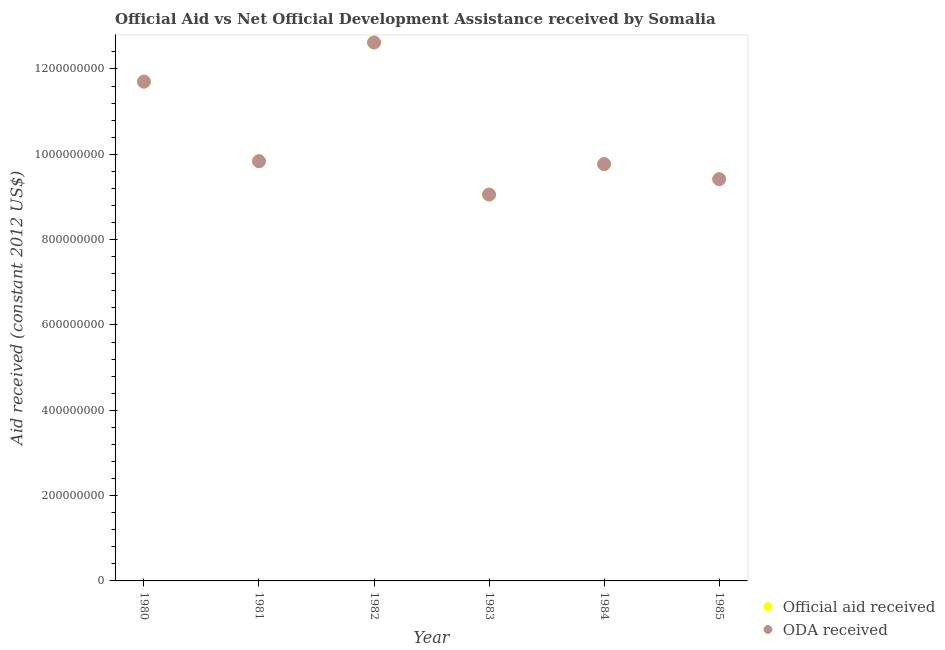How many different coloured dotlines are there?
Your answer should be very brief. 2. Is the number of dotlines equal to the number of legend labels?
Provide a succinct answer. Yes. What is the official aid received in 1984?
Your response must be concise. 9.77e+08. Across all years, what is the maximum oda received?
Your response must be concise. 1.26e+09. Across all years, what is the minimum official aid received?
Keep it short and to the point. 9.06e+08. In which year was the official aid received maximum?
Give a very brief answer. 1982. In which year was the oda received minimum?
Give a very brief answer. 1983. What is the total oda received in the graph?
Keep it short and to the point. 6.24e+09. What is the difference between the oda received in 1983 and that in 1984?
Keep it short and to the point. -7.14e+07. What is the difference between the official aid received in 1981 and the oda received in 1984?
Your answer should be compact. 6.79e+06. What is the average oda received per year?
Keep it short and to the point. 1.04e+09. In the year 1980, what is the difference between the official aid received and oda received?
Your answer should be very brief. 0. What is the ratio of the official aid received in 1981 to that in 1985?
Your answer should be very brief. 1.04. Is the official aid received in 1980 less than that in 1982?
Provide a succinct answer. Yes. What is the difference between the highest and the second highest official aid received?
Provide a succinct answer. 9.18e+07. What is the difference between the highest and the lowest oda received?
Make the answer very short. 3.57e+08. In how many years, is the oda received greater than the average oda received taken over all years?
Your answer should be very brief. 2. Is the sum of the official aid received in 1982 and 1985 greater than the maximum oda received across all years?
Keep it short and to the point. Yes. Does the official aid received monotonically increase over the years?
Provide a short and direct response. No. How many dotlines are there?
Give a very brief answer. 2. What is the difference between two consecutive major ticks on the Y-axis?
Provide a succinct answer. 2.00e+08. Are the values on the major ticks of Y-axis written in scientific E-notation?
Your answer should be compact. No. Does the graph contain any zero values?
Offer a terse response. No. How many legend labels are there?
Make the answer very short. 2. How are the legend labels stacked?
Offer a terse response. Vertical. What is the title of the graph?
Make the answer very short. Official Aid vs Net Official Development Assistance received by Somalia . What is the label or title of the Y-axis?
Your response must be concise. Aid received (constant 2012 US$). What is the Aid received (constant 2012 US$) in Official aid received in 1980?
Your response must be concise. 1.17e+09. What is the Aid received (constant 2012 US$) of ODA received in 1980?
Ensure brevity in your answer.  1.17e+09. What is the Aid received (constant 2012 US$) in Official aid received in 1981?
Your answer should be very brief. 9.84e+08. What is the Aid received (constant 2012 US$) in ODA received in 1981?
Your answer should be very brief. 9.84e+08. What is the Aid received (constant 2012 US$) in Official aid received in 1982?
Offer a terse response. 1.26e+09. What is the Aid received (constant 2012 US$) in ODA received in 1982?
Provide a succinct answer. 1.26e+09. What is the Aid received (constant 2012 US$) of Official aid received in 1983?
Your answer should be very brief. 9.06e+08. What is the Aid received (constant 2012 US$) in ODA received in 1983?
Provide a succinct answer. 9.06e+08. What is the Aid received (constant 2012 US$) of Official aid received in 1984?
Ensure brevity in your answer.  9.77e+08. What is the Aid received (constant 2012 US$) of ODA received in 1984?
Your response must be concise. 9.77e+08. What is the Aid received (constant 2012 US$) of Official aid received in 1985?
Offer a very short reply. 9.42e+08. What is the Aid received (constant 2012 US$) in ODA received in 1985?
Make the answer very short. 9.42e+08. Across all years, what is the maximum Aid received (constant 2012 US$) of Official aid received?
Keep it short and to the point. 1.26e+09. Across all years, what is the maximum Aid received (constant 2012 US$) in ODA received?
Your response must be concise. 1.26e+09. Across all years, what is the minimum Aid received (constant 2012 US$) in Official aid received?
Provide a succinct answer. 9.06e+08. Across all years, what is the minimum Aid received (constant 2012 US$) of ODA received?
Your answer should be very brief. 9.06e+08. What is the total Aid received (constant 2012 US$) of Official aid received in the graph?
Offer a terse response. 6.24e+09. What is the total Aid received (constant 2012 US$) of ODA received in the graph?
Keep it short and to the point. 6.24e+09. What is the difference between the Aid received (constant 2012 US$) of Official aid received in 1980 and that in 1981?
Ensure brevity in your answer.  1.87e+08. What is the difference between the Aid received (constant 2012 US$) of ODA received in 1980 and that in 1981?
Make the answer very short. 1.87e+08. What is the difference between the Aid received (constant 2012 US$) in Official aid received in 1980 and that in 1982?
Make the answer very short. -9.18e+07. What is the difference between the Aid received (constant 2012 US$) of ODA received in 1980 and that in 1982?
Provide a succinct answer. -9.18e+07. What is the difference between the Aid received (constant 2012 US$) of Official aid received in 1980 and that in 1983?
Give a very brief answer. 2.65e+08. What is the difference between the Aid received (constant 2012 US$) in ODA received in 1980 and that in 1983?
Offer a terse response. 2.65e+08. What is the difference between the Aid received (constant 2012 US$) of Official aid received in 1980 and that in 1984?
Offer a terse response. 1.93e+08. What is the difference between the Aid received (constant 2012 US$) of ODA received in 1980 and that in 1984?
Ensure brevity in your answer.  1.93e+08. What is the difference between the Aid received (constant 2012 US$) in Official aid received in 1980 and that in 1985?
Your answer should be very brief. 2.29e+08. What is the difference between the Aid received (constant 2012 US$) in ODA received in 1980 and that in 1985?
Your response must be concise. 2.29e+08. What is the difference between the Aid received (constant 2012 US$) in Official aid received in 1981 and that in 1982?
Your answer should be very brief. -2.78e+08. What is the difference between the Aid received (constant 2012 US$) in ODA received in 1981 and that in 1982?
Your response must be concise. -2.78e+08. What is the difference between the Aid received (constant 2012 US$) in Official aid received in 1981 and that in 1983?
Your answer should be very brief. 7.82e+07. What is the difference between the Aid received (constant 2012 US$) in ODA received in 1981 and that in 1983?
Ensure brevity in your answer.  7.82e+07. What is the difference between the Aid received (constant 2012 US$) in Official aid received in 1981 and that in 1984?
Provide a succinct answer. 6.79e+06. What is the difference between the Aid received (constant 2012 US$) in ODA received in 1981 and that in 1984?
Offer a terse response. 6.79e+06. What is the difference between the Aid received (constant 2012 US$) in Official aid received in 1981 and that in 1985?
Offer a terse response. 4.21e+07. What is the difference between the Aid received (constant 2012 US$) of ODA received in 1981 and that in 1985?
Your response must be concise. 4.21e+07. What is the difference between the Aid received (constant 2012 US$) in Official aid received in 1982 and that in 1983?
Ensure brevity in your answer.  3.57e+08. What is the difference between the Aid received (constant 2012 US$) of ODA received in 1982 and that in 1983?
Offer a terse response. 3.57e+08. What is the difference between the Aid received (constant 2012 US$) of Official aid received in 1982 and that in 1984?
Your answer should be very brief. 2.85e+08. What is the difference between the Aid received (constant 2012 US$) of ODA received in 1982 and that in 1984?
Your answer should be compact. 2.85e+08. What is the difference between the Aid received (constant 2012 US$) of Official aid received in 1982 and that in 1985?
Offer a terse response. 3.20e+08. What is the difference between the Aid received (constant 2012 US$) in ODA received in 1982 and that in 1985?
Ensure brevity in your answer.  3.20e+08. What is the difference between the Aid received (constant 2012 US$) in Official aid received in 1983 and that in 1984?
Ensure brevity in your answer.  -7.14e+07. What is the difference between the Aid received (constant 2012 US$) in ODA received in 1983 and that in 1984?
Provide a succinct answer. -7.14e+07. What is the difference between the Aid received (constant 2012 US$) of Official aid received in 1983 and that in 1985?
Give a very brief answer. -3.61e+07. What is the difference between the Aid received (constant 2012 US$) in ODA received in 1983 and that in 1985?
Ensure brevity in your answer.  -3.61e+07. What is the difference between the Aid received (constant 2012 US$) in Official aid received in 1984 and that in 1985?
Your answer should be compact. 3.53e+07. What is the difference between the Aid received (constant 2012 US$) of ODA received in 1984 and that in 1985?
Keep it short and to the point. 3.53e+07. What is the difference between the Aid received (constant 2012 US$) in Official aid received in 1980 and the Aid received (constant 2012 US$) in ODA received in 1981?
Give a very brief answer. 1.87e+08. What is the difference between the Aid received (constant 2012 US$) in Official aid received in 1980 and the Aid received (constant 2012 US$) in ODA received in 1982?
Offer a very short reply. -9.18e+07. What is the difference between the Aid received (constant 2012 US$) of Official aid received in 1980 and the Aid received (constant 2012 US$) of ODA received in 1983?
Make the answer very short. 2.65e+08. What is the difference between the Aid received (constant 2012 US$) in Official aid received in 1980 and the Aid received (constant 2012 US$) in ODA received in 1984?
Ensure brevity in your answer.  1.93e+08. What is the difference between the Aid received (constant 2012 US$) of Official aid received in 1980 and the Aid received (constant 2012 US$) of ODA received in 1985?
Provide a succinct answer. 2.29e+08. What is the difference between the Aid received (constant 2012 US$) of Official aid received in 1981 and the Aid received (constant 2012 US$) of ODA received in 1982?
Offer a very short reply. -2.78e+08. What is the difference between the Aid received (constant 2012 US$) in Official aid received in 1981 and the Aid received (constant 2012 US$) in ODA received in 1983?
Provide a succinct answer. 7.82e+07. What is the difference between the Aid received (constant 2012 US$) in Official aid received in 1981 and the Aid received (constant 2012 US$) in ODA received in 1984?
Give a very brief answer. 6.79e+06. What is the difference between the Aid received (constant 2012 US$) in Official aid received in 1981 and the Aid received (constant 2012 US$) in ODA received in 1985?
Your answer should be compact. 4.21e+07. What is the difference between the Aid received (constant 2012 US$) in Official aid received in 1982 and the Aid received (constant 2012 US$) in ODA received in 1983?
Give a very brief answer. 3.57e+08. What is the difference between the Aid received (constant 2012 US$) in Official aid received in 1982 and the Aid received (constant 2012 US$) in ODA received in 1984?
Make the answer very short. 2.85e+08. What is the difference between the Aid received (constant 2012 US$) of Official aid received in 1982 and the Aid received (constant 2012 US$) of ODA received in 1985?
Offer a terse response. 3.20e+08. What is the difference between the Aid received (constant 2012 US$) of Official aid received in 1983 and the Aid received (constant 2012 US$) of ODA received in 1984?
Provide a short and direct response. -7.14e+07. What is the difference between the Aid received (constant 2012 US$) in Official aid received in 1983 and the Aid received (constant 2012 US$) in ODA received in 1985?
Offer a terse response. -3.61e+07. What is the difference between the Aid received (constant 2012 US$) of Official aid received in 1984 and the Aid received (constant 2012 US$) of ODA received in 1985?
Your answer should be very brief. 3.53e+07. What is the average Aid received (constant 2012 US$) of Official aid received per year?
Your answer should be compact. 1.04e+09. What is the average Aid received (constant 2012 US$) in ODA received per year?
Keep it short and to the point. 1.04e+09. In the year 1983, what is the difference between the Aid received (constant 2012 US$) in Official aid received and Aid received (constant 2012 US$) in ODA received?
Provide a short and direct response. 0. In the year 1984, what is the difference between the Aid received (constant 2012 US$) in Official aid received and Aid received (constant 2012 US$) in ODA received?
Provide a short and direct response. 0. What is the ratio of the Aid received (constant 2012 US$) of Official aid received in 1980 to that in 1981?
Your answer should be very brief. 1.19. What is the ratio of the Aid received (constant 2012 US$) in ODA received in 1980 to that in 1981?
Ensure brevity in your answer.  1.19. What is the ratio of the Aid received (constant 2012 US$) of Official aid received in 1980 to that in 1982?
Keep it short and to the point. 0.93. What is the ratio of the Aid received (constant 2012 US$) of ODA received in 1980 to that in 1982?
Offer a very short reply. 0.93. What is the ratio of the Aid received (constant 2012 US$) in Official aid received in 1980 to that in 1983?
Your response must be concise. 1.29. What is the ratio of the Aid received (constant 2012 US$) of ODA received in 1980 to that in 1983?
Your response must be concise. 1.29. What is the ratio of the Aid received (constant 2012 US$) in Official aid received in 1980 to that in 1984?
Provide a succinct answer. 1.2. What is the ratio of the Aid received (constant 2012 US$) of ODA received in 1980 to that in 1984?
Keep it short and to the point. 1.2. What is the ratio of the Aid received (constant 2012 US$) of Official aid received in 1980 to that in 1985?
Ensure brevity in your answer.  1.24. What is the ratio of the Aid received (constant 2012 US$) of ODA received in 1980 to that in 1985?
Keep it short and to the point. 1.24. What is the ratio of the Aid received (constant 2012 US$) in Official aid received in 1981 to that in 1982?
Ensure brevity in your answer.  0.78. What is the ratio of the Aid received (constant 2012 US$) of ODA received in 1981 to that in 1982?
Keep it short and to the point. 0.78. What is the ratio of the Aid received (constant 2012 US$) of Official aid received in 1981 to that in 1983?
Your answer should be very brief. 1.09. What is the ratio of the Aid received (constant 2012 US$) in ODA received in 1981 to that in 1983?
Keep it short and to the point. 1.09. What is the ratio of the Aid received (constant 2012 US$) in Official aid received in 1981 to that in 1985?
Ensure brevity in your answer.  1.04. What is the ratio of the Aid received (constant 2012 US$) of ODA received in 1981 to that in 1985?
Offer a terse response. 1.04. What is the ratio of the Aid received (constant 2012 US$) of Official aid received in 1982 to that in 1983?
Ensure brevity in your answer.  1.39. What is the ratio of the Aid received (constant 2012 US$) of ODA received in 1982 to that in 1983?
Offer a very short reply. 1.39. What is the ratio of the Aid received (constant 2012 US$) of Official aid received in 1982 to that in 1984?
Your answer should be compact. 1.29. What is the ratio of the Aid received (constant 2012 US$) in ODA received in 1982 to that in 1984?
Give a very brief answer. 1.29. What is the ratio of the Aid received (constant 2012 US$) of Official aid received in 1982 to that in 1985?
Provide a short and direct response. 1.34. What is the ratio of the Aid received (constant 2012 US$) in ODA received in 1982 to that in 1985?
Give a very brief answer. 1.34. What is the ratio of the Aid received (constant 2012 US$) of Official aid received in 1983 to that in 1984?
Give a very brief answer. 0.93. What is the ratio of the Aid received (constant 2012 US$) in ODA received in 1983 to that in 1984?
Make the answer very short. 0.93. What is the ratio of the Aid received (constant 2012 US$) in Official aid received in 1983 to that in 1985?
Your answer should be very brief. 0.96. What is the ratio of the Aid received (constant 2012 US$) in ODA received in 1983 to that in 1985?
Offer a very short reply. 0.96. What is the ratio of the Aid received (constant 2012 US$) of Official aid received in 1984 to that in 1985?
Keep it short and to the point. 1.04. What is the ratio of the Aid received (constant 2012 US$) of ODA received in 1984 to that in 1985?
Ensure brevity in your answer.  1.04. What is the difference between the highest and the second highest Aid received (constant 2012 US$) in Official aid received?
Offer a terse response. 9.18e+07. What is the difference between the highest and the second highest Aid received (constant 2012 US$) of ODA received?
Ensure brevity in your answer.  9.18e+07. What is the difference between the highest and the lowest Aid received (constant 2012 US$) in Official aid received?
Keep it short and to the point. 3.57e+08. What is the difference between the highest and the lowest Aid received (constant 2012 US$) of ODA received?
Your answer should be very brief. 3.57e+08. 